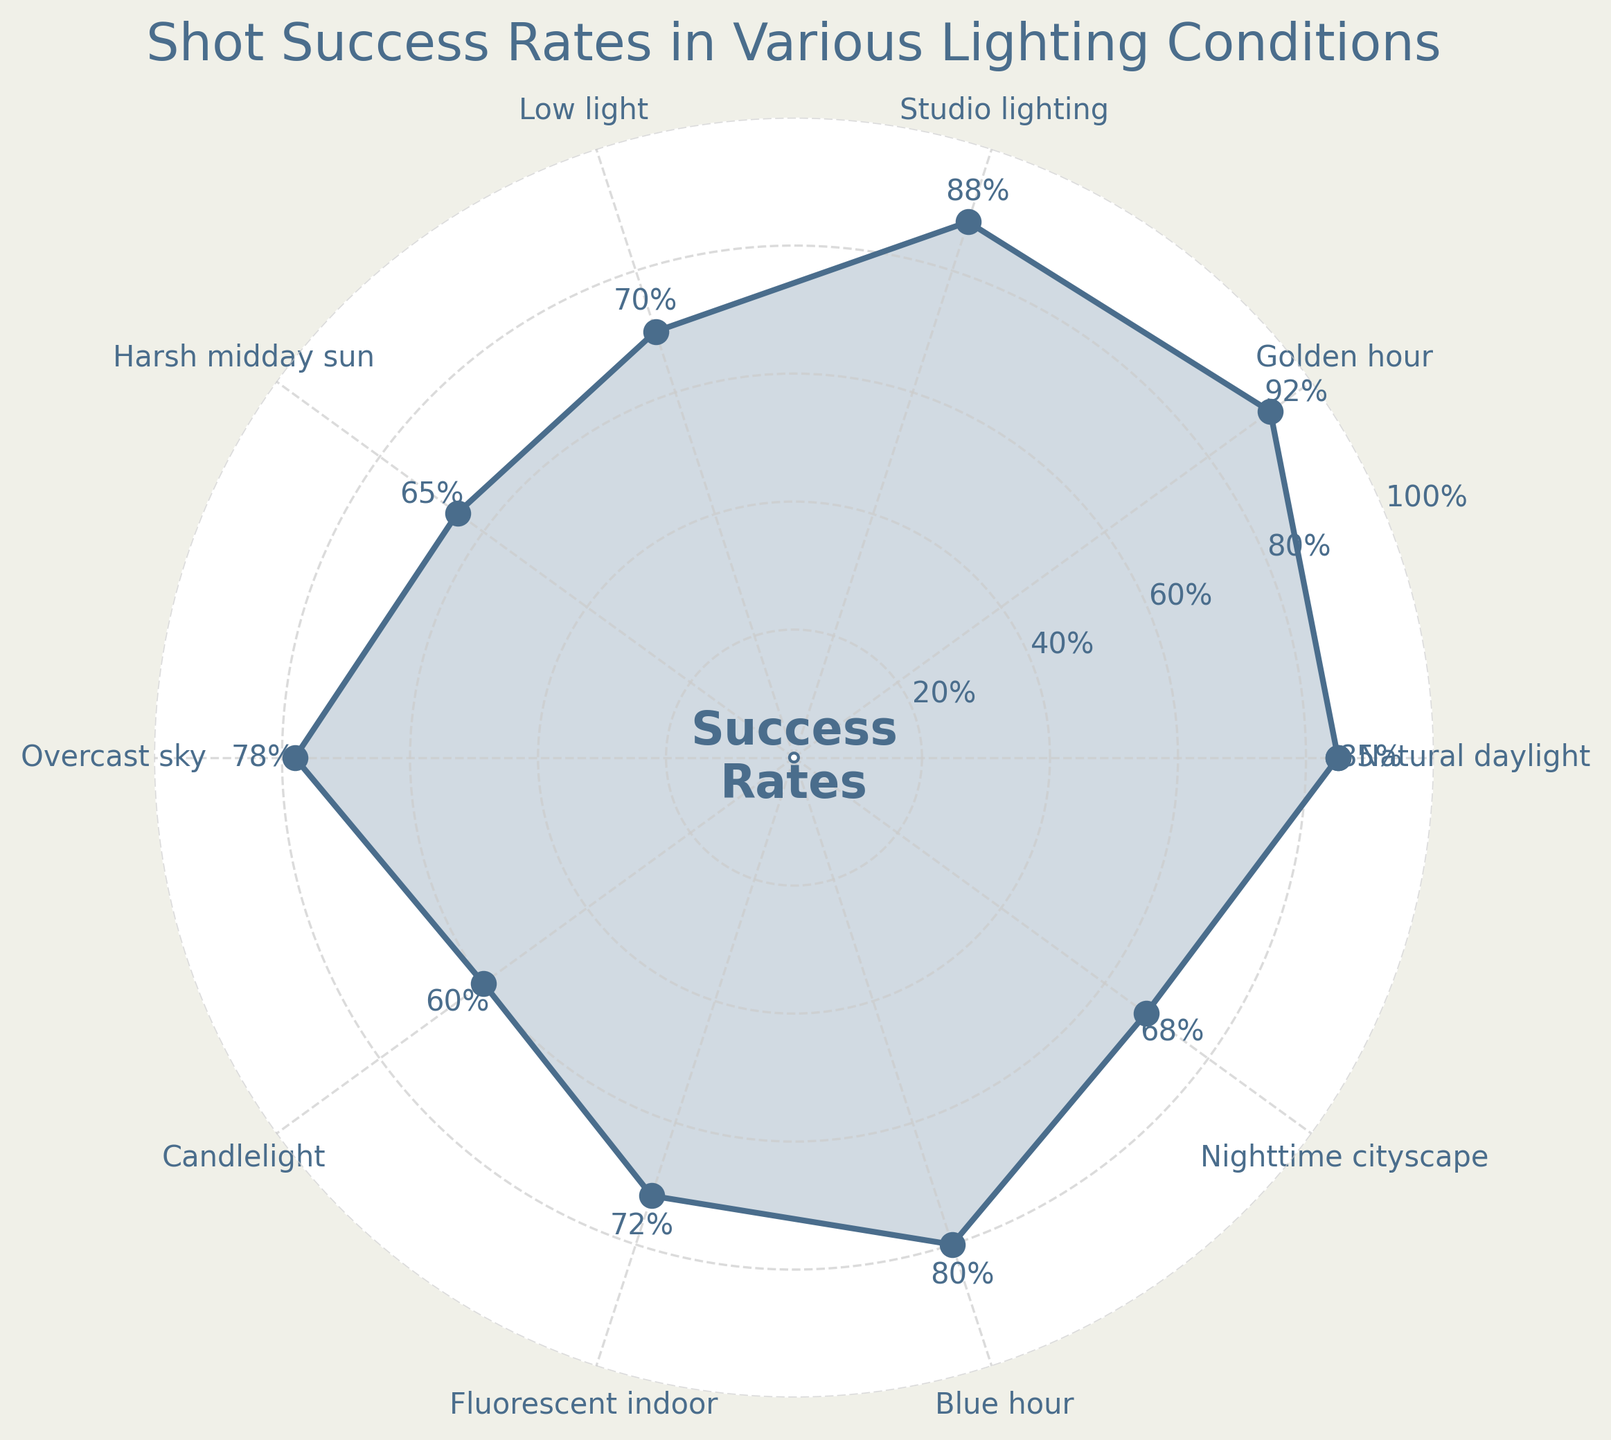What are the lighting conditions displayed in the figure? The figure shows different lighting conditions around the circle. By reading the labels placed around the plot, we observe the conditions listed.
Answer: Natural daylight, Golden hour, Studio lighting, Low light, Harsh midday sun, Overcast sky, Candlelight, Fluorescent indoor, Blue hour, Nighttime cityscape Which lighting condition has the highest percentage of successful shots? Observing the radial plot, the highest data point is labeled "92%" positioned at "Golden hour".
Answer: Golden hour What is the success rate for nighttime cityscape shoots? By locating "Nighttime cityscape" on the radial plot and reading the value closest to it, we see it is marked "68%".
Answer: 68% What is the difference in success rate between candlelight and studio lighting? Candlelight is at 60% and studio lighting is at 88%. Subtraction gives the result: 88% - 60% = 28%.
Answer: 28% What is the average success rate across all lighting conditions? Sum all rates: 85 + 92 + 88 + 70 + 65 + 78 + 60 + 72 + 80 + 68 = 758. There are 10 conditions, so the average: 758 / 10 = 75.8%.
Answer: 75.8% Which lighting condition has a lower success rate: overcast sky or fluorescent indoor? Overcast sky is 78%, and Fluorescent indoor is 72%. 72% < 78%.
Answer: Fluorescent indoor Are there any lighting conditions where the success rate is below 50%? All displayed percentages range above 50%, so the answer is none.
Answer: None What is the median success rate? Arrange rates in order: 60, 65, 68, 70, 72, 78, 80, 85, 88, 92. The median is the middle value: (78 + 80) / 2 = 79%.
Answer: 79% What is the second lowest success rate and which condition does it correspond to? The second lowest rate after arranging them is 65%, which corresponds to Harsh midday sun.
Answer: Harsh midday sun, 65% 